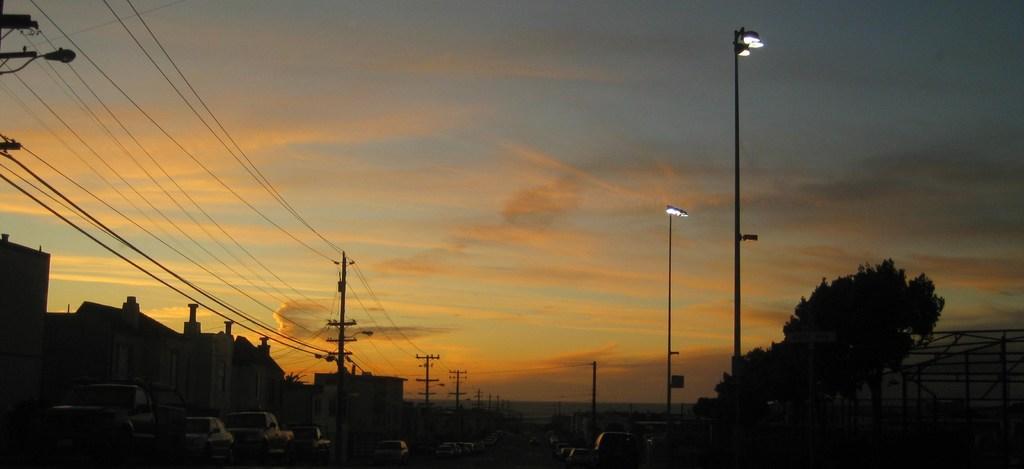Please provide a concise description of this image. On the left side, there are vehicles, there are poles having electric lines and there are buildings. On the right side, there are lights attached to the poles and there are trees. In the background, there are clouds in the sky. 